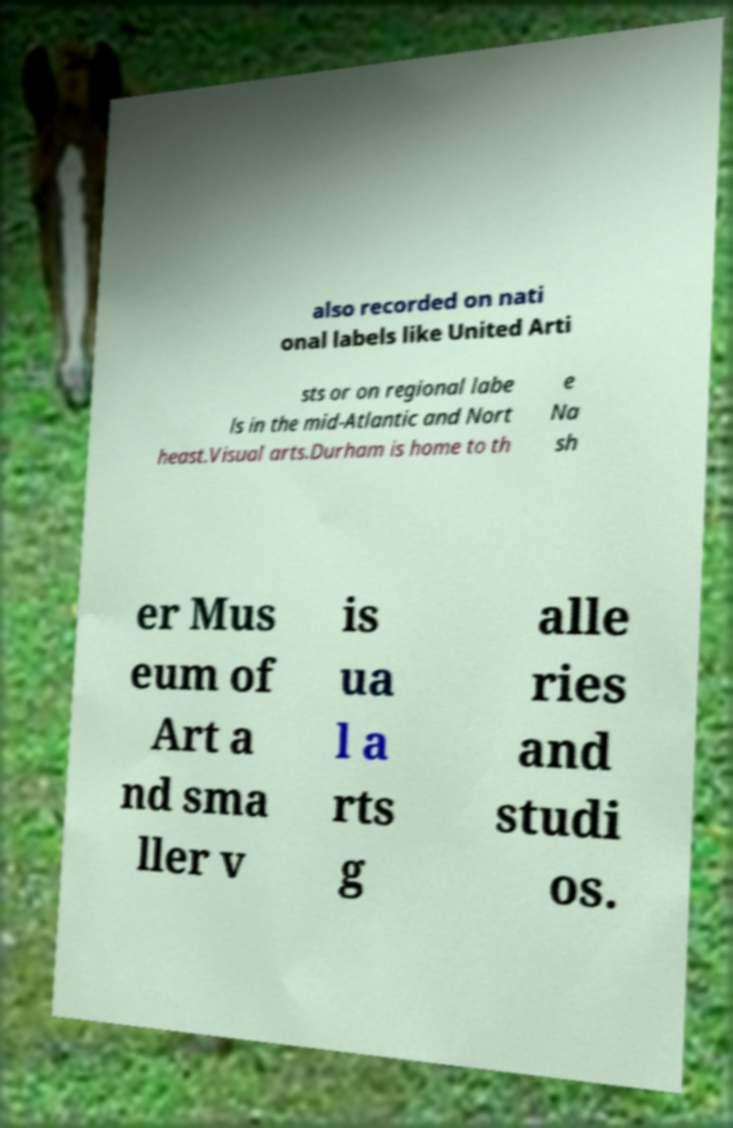Can you read and provide the text displayed in the image?This photo seems to have some interesting text. Can you extract and type it out for me? also recorded on nati onal labels like United Arti sts or on regional labe ls in the mid-Atlantic and Nort heast.Visual arts.Durham is home to th e Na sh er Mus eum of Art a nd sma ller v is ua l a rts g alle ries and studi os. 